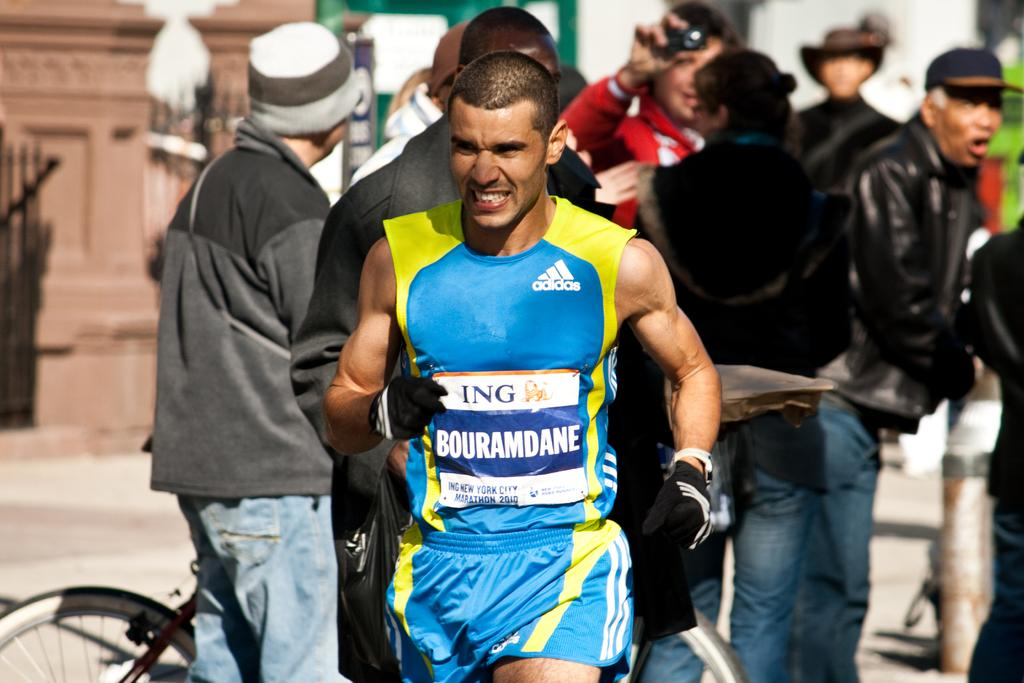<image>
Share a concise interpretation of the image provided. A man pumps his arms as he competes in the New York City Marathon. 